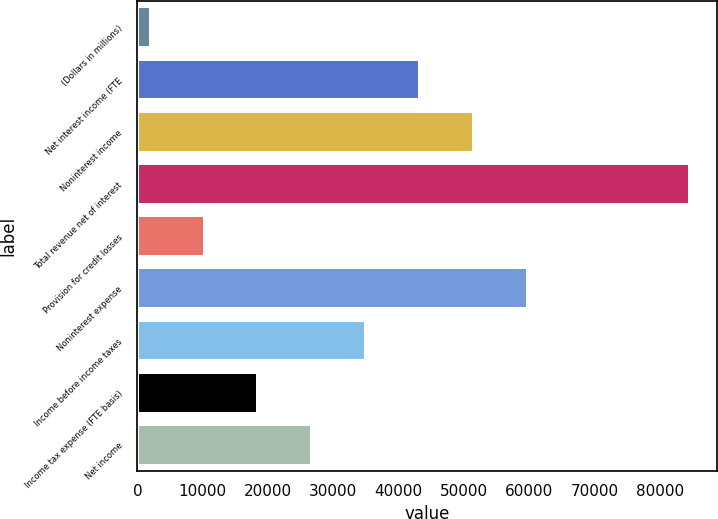Convert chart to OTSL. <chart><loc_0><loc_0><loc_500><loc_500><bar_chart><fcel>(Dollars in millions)<fcel>Net interest income (FTE<fcel>Noninterest income<fcel>Total revenue net of interest<fcel>Provision for credit losses<fcel>Noninterest expense<fcel>Income before income taxes<fcel>Income tax expense (FTE basis)<fcel>Net income<nl><fcel>2016<fcel>43308.5<fcel>51567<fcel>84601<fcel>10274.5<fcel>59825.5<fcel>35050<fcel>18533<fcel>26791.5<nl></chart> 